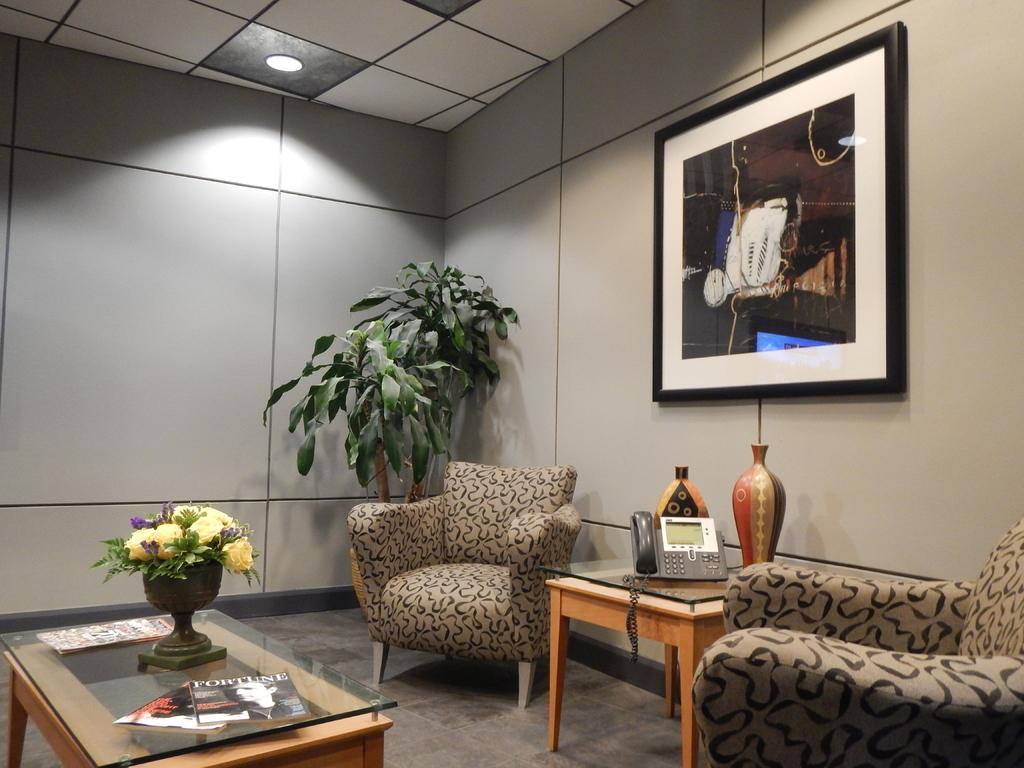Please provide a concise description of this image. This picture is clicked inside the room. In the right bottom of the picture, we see a table on which telephone and flask is present. Behind that, we see a wall on which photo frame is placed. Beside the table, we see another sofa chair and plant. To the left bottom of the picture, we see a table on which books and flower pot is placed. On the right, on the top of the picture, we see the roof of that room. 